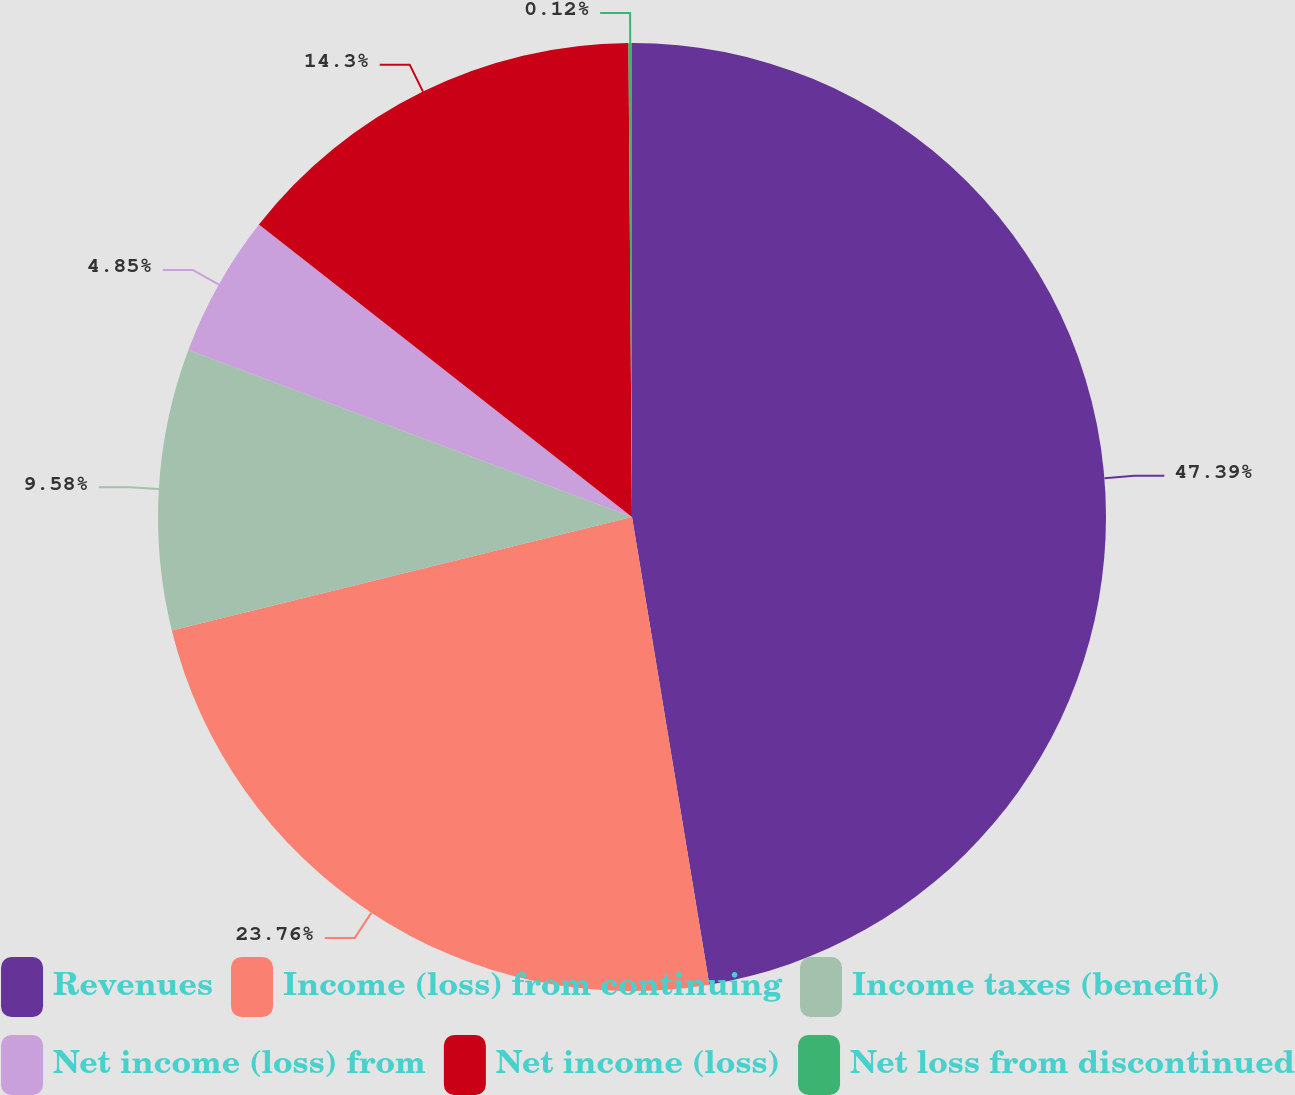Convert chart. <chart><loc_0><loc_0><loc_500><loc_500><pie_chart><fcel>Revenues<fcel>Income (loss) from continuing<fcel>Income taxes (benefit)<fcel>Net income (loss) from<fcel>Net income (loss)<fcel>Net loss from discontinued<nl><fcel>47.39%<fcel>23.76%<fcel>9.58%<fcel>4.85%<fcel>14.3%<fcel>0.12%<nl></chart> 